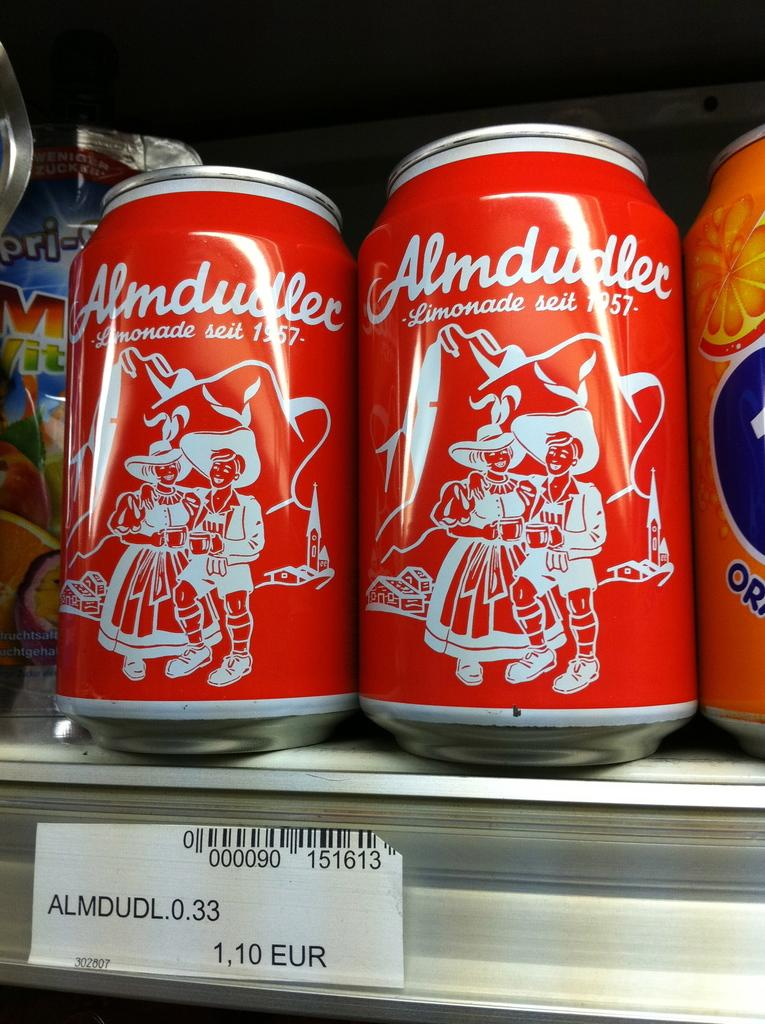<image>
Present a compact description of the photo's key features. A red canned beverage is called Almdudlex and has the date 1957 on it. 